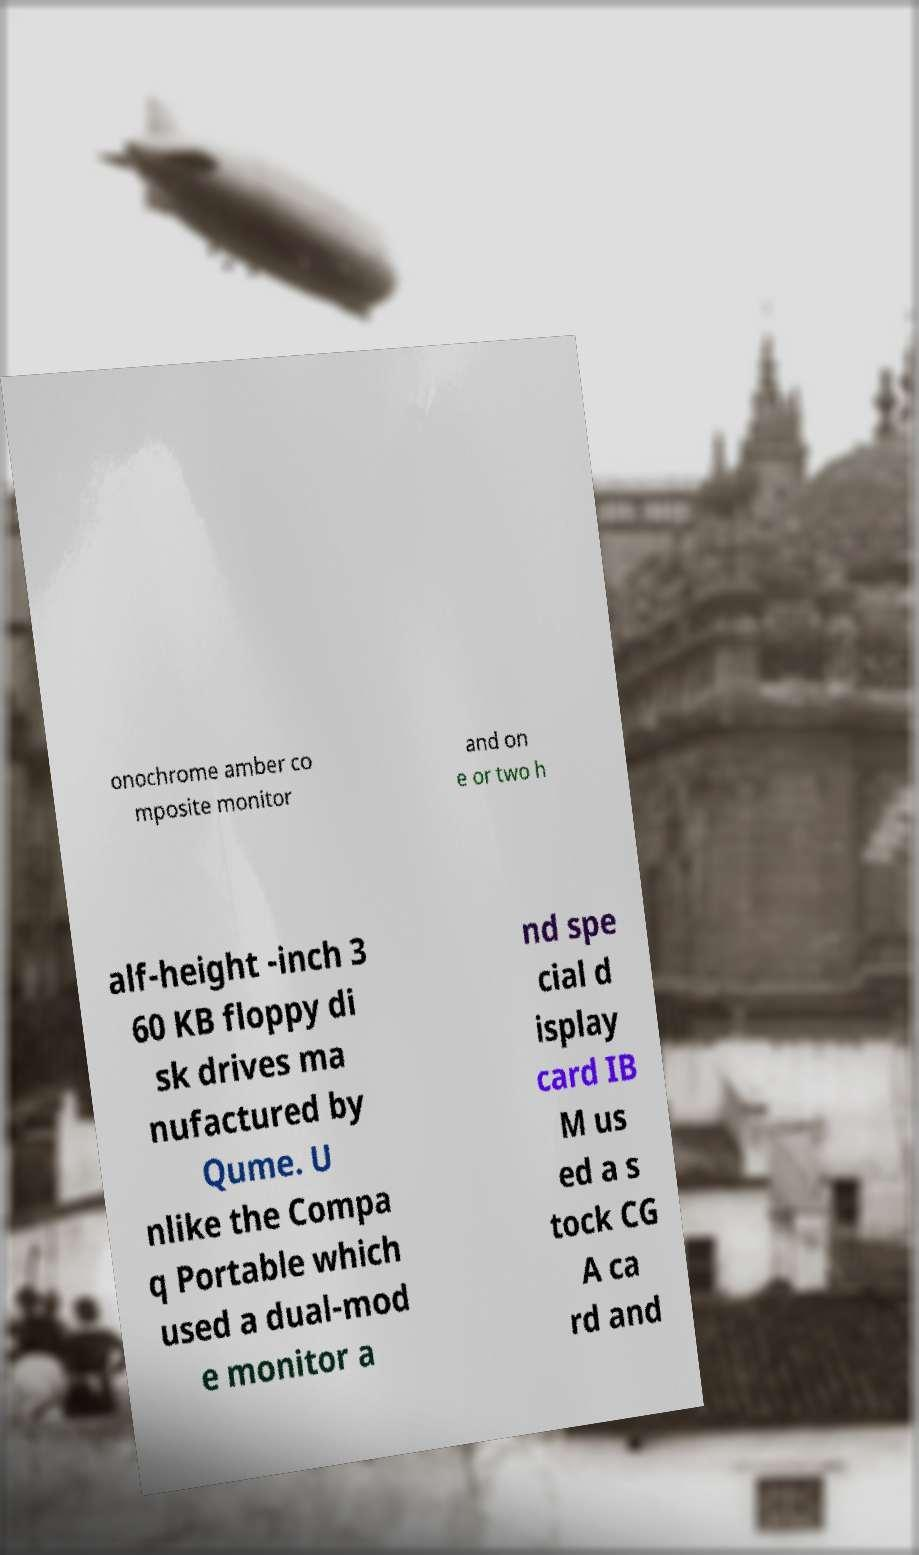There's text embedded in this image that I need extracted. Can you transcribe it verbatim? onochrome amber co mposite monitor and on e or two h alf-height -inch 3 60 KB floppy di sk drives ma nufactured by Qume. U nlike the Compa q Portable which used a dual-mod e monitor a nd spe cial d isplay card IB M us ed a s tock CG A ca rd and 